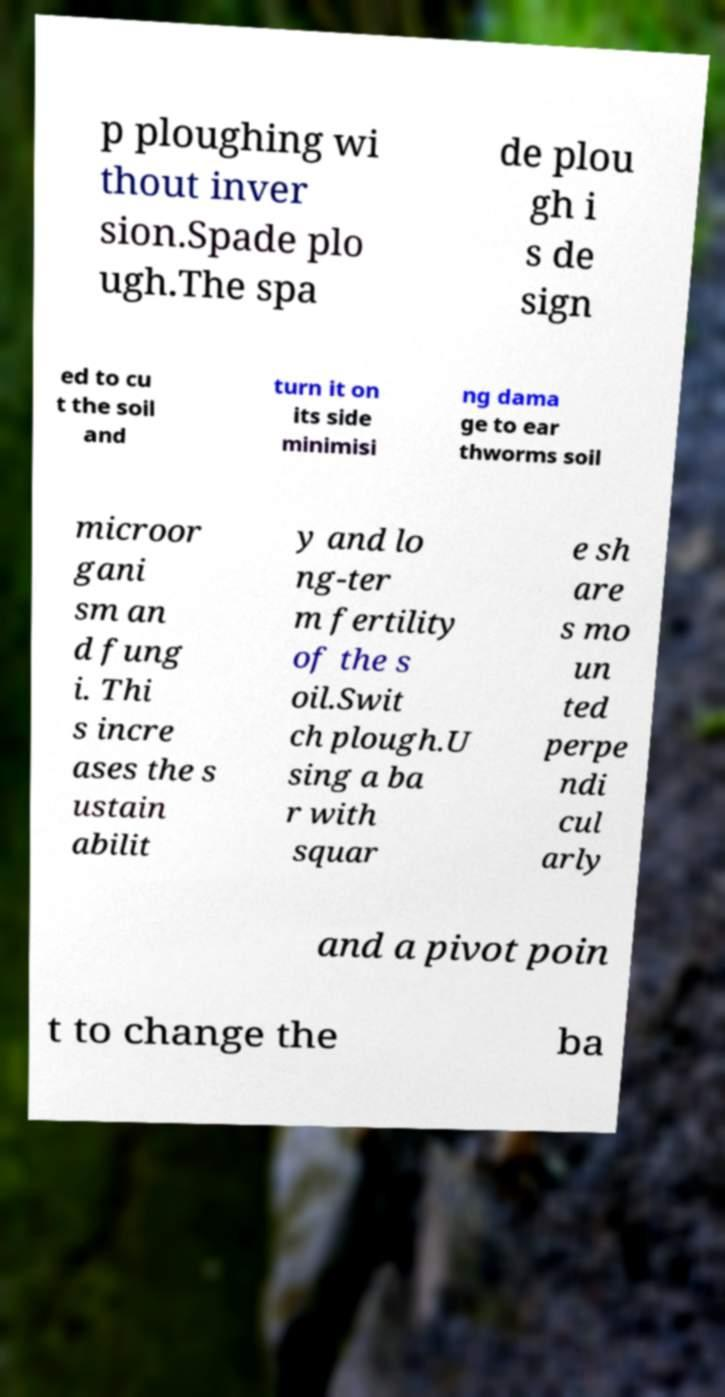Can you read and provide the text displayed in the image?This photo seems to have some interesting text. Can you extract and type it out for me? p ploughing wi thout inver sion.Spade plo ugh.The spa de plou gh i s de sign ed to cu t the soil and turn it on its side minimisi ng dama ge to ear thworms soil microor gani sm an d fung i. Thi s incre ases the s ustain abilit y and lo ng-ter m fertility of the s oil.Swit ch plough.U sing a ba r with squar e sh are s mo un ted perpe ndi cul arly and a pivot poin t to change the ba 